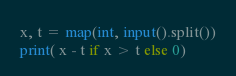Convert code to text. <code><loc_0><loc_0><loc_500><loc_500><_Python_>x, t = map(int, input().split())
print( x - t if x > t else 0)</code> 